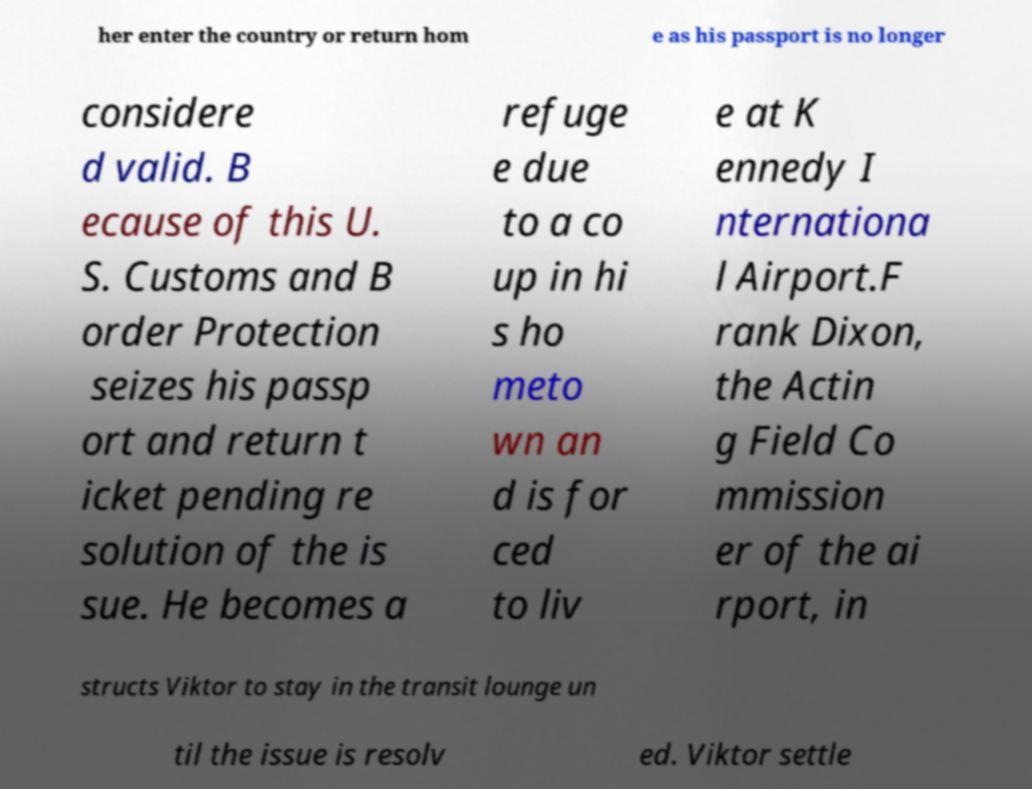Can you read and provide the text displayed in the image?This photo seems to have some interesting text. Can you extract and type it out for me? her enter the country or return hom e as his passport is no longer considere d valid. B ecause of this U. S. Customs and B order Protection seizes his passp ort and return t icket pending re solution of the is sue. He becomes a refuge e due to a co up in hi s ho meto wn an d is for ced to liv e at K ennedy I nternationa l Airport.F rank Dixon, the Actin g Field Co mmission er of the ai rport, in structs Viktor to stay in the transit lounge un til the issue is resolv ed. Viktor settle 